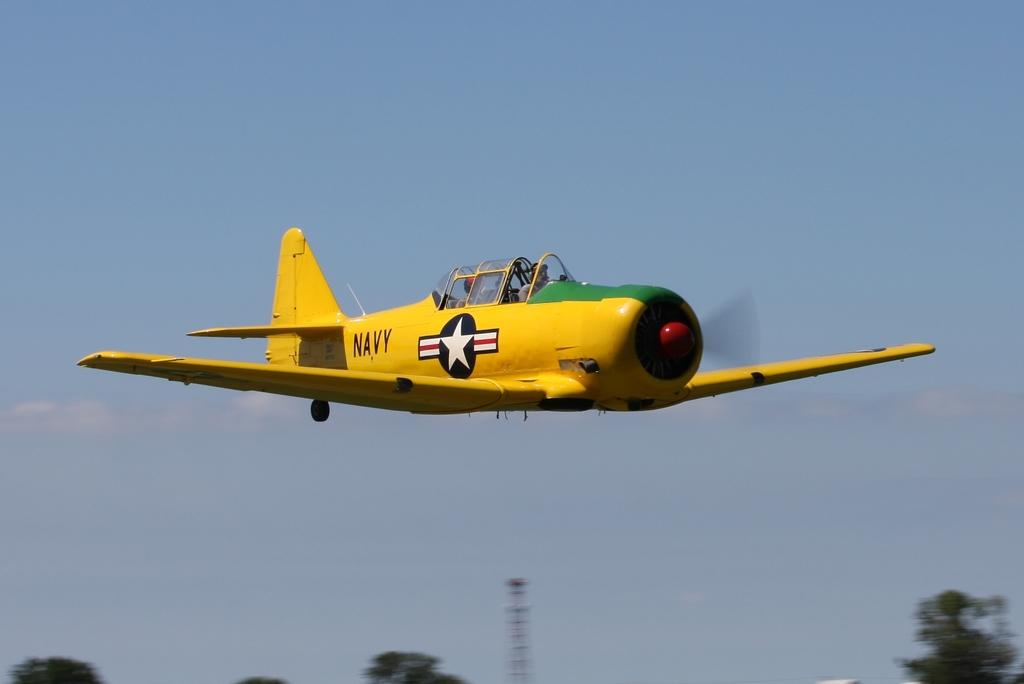What division is this plane for?
Offer a terse response. Navy. 